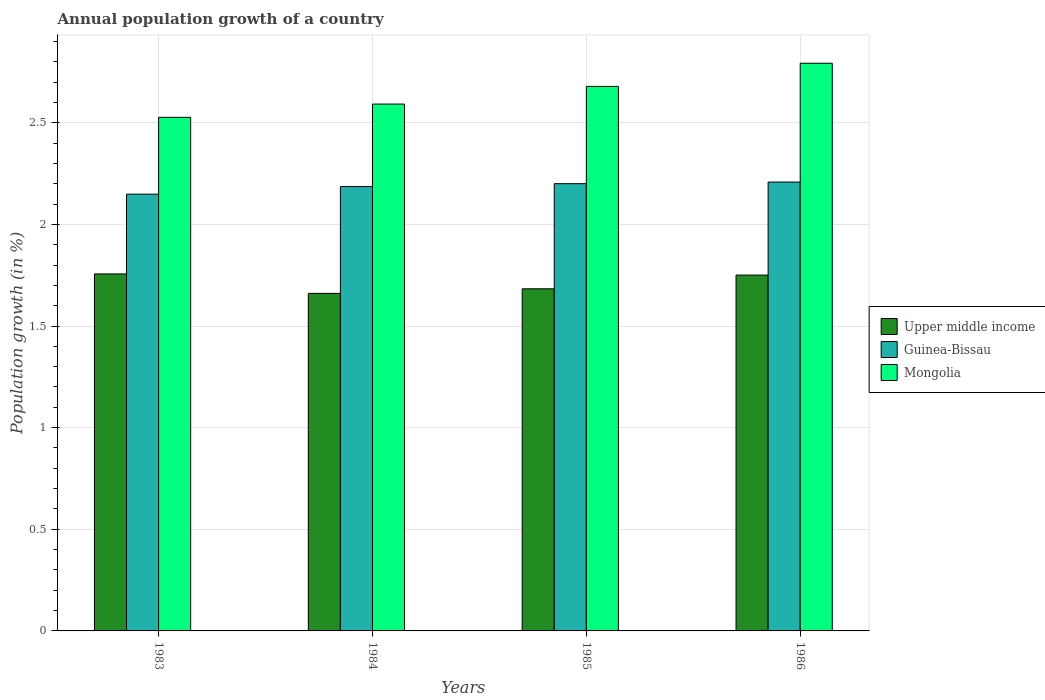How many groups of bars are there?
Provide a succinct answer. 4. Are the number of bars per tick equal to the number of legend labels?
Ensure brevity in your answer.  Yes. Are the number of bars on each tick of the X-axis equal?
Offer a very short reply. Yes. What is the label of the 2nd group of bars from the left?
Give a very brief answer. 1984. What is the annual population growth in Mongolia in 1986?
Give a very brief answer. 2.79. Across all years, what is the maximum annual population growth in Mongolia?
Keep it short and to the point. 2.79. Across all years, what is the minimum annual population growth in Guinea-Bissau?
Your response must be concise. 2.15. In which year was the annual population growth in Upper middle income minimum?
Offer a very short reply. 1984. What is the total annual population growth in Upper middle income in the graph?
Give a very brief answer. 6.85. What is the difference between the annual population growth in Upper middle income in 1983 and that in 1984?
Offer a terse response. 0.1. What is the difference between the annual population growth in Upper middle income in 1983 and the annual population growth in Mongolia in 1984?
Make the answer very short. -0.84. What is the average annual population growth in Upper middle income per year?
Offer a very short reply. 1.71. In the year 1985, what is the difference between the annual population growth in Guinea-Bissau and annual population growth in Upper middle income?
Ensure brevity in your answer.  0.52. What is the ratio of the annual population growth in Guinea-Bissau in 1983 to that in 1984?
Provide a short and direct response. 0.98. Is the difference between the annual population growth in Guinea-Bissau in 1984 and 1986 greater than the difference between the annual population growth in Upper middle income in 1984 and 1986?
Ensure brevity in your answer.  Yes. What is the difference between the highest and the second highest annual population growth in Mongolia?
Offer a very short reply. 0.11. What is the difference between the highest and the lowest annual population growth in Guinea-Bissau?
Offer a very short reply. 0.06. In how many years, is the annual population growth in Mongolia greater than the average annual population growth in Mongolia taken over all years?
Your answer should be compact. 2. Is the sum of the annual population growth in Mongolia in 1985 and 1986 greater than the maximum annual population growth in Upper middle income across all years?
Make the answer very short. Yes. What does the 3rd bar from the left in 1983 represents?
Keep it short and to the point. Mongolia. What does the 1st bar from the right in 1983 represents?
Make the answer very short. Mongolia. Is it the case that in every year, the sum of the annual population growth in Mongolia and annual population growth in Upper middle income is greater than the annual population growth in Guinea-Bissau?
Offer a very short reply. Yes. Are all the bars in the graph horizontal?
Your answer should be compact. No. What is the difference between two consecutive major ticks on the Y-axis?
Ensure brevity in your answer.  0.5. Are the values on the major ticks of Y-axis written in scientific E-notation?
Provide a succinct answer. No. Does the graph contain grids?
Your answer should be very brief. Yes. Where does the legend appear in the graph?
Keep it short and to the point. Center right. What is the title of the graph?
Provide a succinct answer. Annual population growth of a country. What is the label or title of the Y-axis?
Your answer should be very brief. Population growth (in %). What is the Population growth (in %) in Upper middle income in 1983?
Your answer should be very brief. 1.76. What is the Population growth (in %) in Guinea-Bissau in 1983?
Make the answer very short. 2.15. What is the Population growth (in %) in Mongolia in 1983?
Keep it short and to the point. 2.53. What is the Population growth (in %) in Upper middle income in 1984?
Provide a short and direct response. 1.66. What is the Population growth (in %) of Guinea-Bissau in 1984?
Keep it short and to the point. 2.19. What is the Population growth (in %) of Mongolia in 1984?
Your answer should be very brief. 2.59. What is the Population growth (in %) in Upper middle income in 1985?
Your response must be concise. 1.68. What is the Population growth (in %) of Guinea-Bissau in 1985?
Your answer should be compact. 2.2. What is the Population growth (in %) in Mongolia in 1985?
Provide a succinct answer. 2.68. What is the Population growth (in %) in Upper middle income in 1986?
Provide a short and direct response. 1.75. What is the Population growth (in %) of Guinea-Bissau in 1986?
Your answer should be compact. 2.21. What is the Population growth (in %) in Mongolia in 1986?
Ensure brevity in your answer.  2.79. Across all years, what is the maximum Population growth (in %) of Upper middle income?
Ensure brevity in your answer.  1.76. Across all years, what is the maximum Population growth (in %) in Guinea-Bissau?
Keep it short and to the point. 2.21. Across all years, what is the maximum Population growth (in %) in Mongolia?
Your response must be concise. 2.79. Across all years, what is the minimum Population growth (in %) of Upper middle income?
Keep it short and to the point. 1.66. Across all years, what is the minimum Population growth (in %) of Guinea-Bissau?
Your answer should be compact. 2.15. Across all years, what is the minimum Population growth (in %) of Mongolia?
Your answer should be very brief. 2.53. What is the total Population growth (in %) of Upper middle income in the graph?
Your answer should be compact. 6.85. What is the total Population growth (in %) of Guinea-Bissau in the graph?
Keep it short and to the point. 8.74. What is the total Population growth (in %) of Mongolia in the graph?
Your answer should be very brief. 10.59. What is the difference between the Population growth (in %) in Upper middle income in 1983 and that in 1984?
Ensure brevity in your answer.  0.1. What is the difference between the Population growth (in %) of Guinea-Bissau in 1983 and that in 1984?
Make the answer very short. -0.04. What is the difference between the Population growth (in %) of Mongolia in 1983 and that in 1984?
Your answer should be compact. -0.07. What is the difference between the Population growth (in %) in Upper middle income in 1983 and that in 1985?
Your answer should be very brief. 0.07. What is the difference between the Population growth (in %) in Guinea-Bissau in 1983 and that in 1985?
Provide a short and direct response. -0.05. What is the difference between the Population growth (in %) of Mongolia in 1983 and that in 1985?
Provide a short and direct response. -0.15. What is the difference between the Population growth (in %) of Upper middle income in 1983 and that in 1986?
Provide a succinct answer. 0.01. What is the difference between the Population growth (in %) in Guinea-Bissau in 1983 and that in 1986?
Make the answer very short. -0.06. What is the difference between the Population growth (in %) of Mongolia in 1983 and that in 1986?
Your response must be concise. -0.27. What is the difference between the Population growth (in %) in Upper middle income in 1984 and that in 1985?
Make the answer very short. -0.02. What is the difference between the Population growth (in %) of Guinea-Bissau in 1984 and that in 1985?
Your answer should be very brief. -0.01. What is the difference between the Population growth (in %) of Mongolia in 1984 and that in 1985?
Provide a short and direct response. -0.09. What is the difference between the Population growth (in %) of Upper middle income in 1984 and that in 1986?
Provide a short and direct response. -0.09. What is the difference between the Population growth (in %) in Guinea-Bissau in 1984 and that in 1986?
Your answer should be compact. -0.02. What is the difference between the Population growth (in %) of Mongolia in 1984 and that in 1986?
Your response must be concise. -0.2. What is the difference between the Population growth (in %) of Upper middle income in 1985 and that in 1986?
Your response must be concise. -0.07. What is the difference between the Population growth (in %) in Guinea-Bissau in 1985 and that in 1986?
Keep it short and to the point. -0.01. What is the difference between the Population growth (in %) in Mongolia in 1985 and that in 1986?
Your answer should be very brief. -0.11. What is the difference between the Population growth (in %) in Upper middle income in 1983 and the Population growth (in %) in Guinea-Bissau in 1984?
Provide a succinct answer. -0.43. What is the difference between the Population growth (in %) in Upper middle income in 1983 and the Population growth (in %) in Mongolia in 1984?
Your answer should be compact. -0.84. What is the difference between the Population growth (in %) in Guinea-Bissau in 1983 and the Population growth (in %) in Mongolia in 1984?
Ensure brevity in your answer.  -0.44. What is the difference between the Population growth (in %) in Upper middle income in 1983 and the Population growth (in %) in Guinea-Bissau in 1985?
Offer a very short reply. -0.44. What is the difference between the Population growth (in %) of Upper middle income in 1983 and the Population growth (in %) of Mongolia in 1985?
Your answer should be compact. -0.92. What is the difference between the Population growth (in %) in Guinea-Bissau in 1983 and the Population growth (in %) in Mongolia in 1985?
Ensure brevity in your answer.  -0.53. What is the difference between the Population growth (in %) of Upper middle income in 1983 and the Population growth (in %) of Guinea-Bissau in 1986?
Your answer should be very brief. -0.45. What is the difference between the Population growth (in %) in Upper middle income in 1983 and the Population growth (in %) in Mongolia in 1986?
Provide a succinct answer. -1.04. What is the difference between the Population growth (in %) in Guinea-Bissau in 1983 and the Population growth (in %) in Mongolia in 1986?
Offer a very short reply. -0.64. What is the difference between the Population growth (in %) of Upper middle income in 1984 and the Population growth (in %) of Guinea-Bissau in 1985?
Provide a succinct answer. -0.54. What is the difference between the Population growth (in %) of Upper middle income in 1984 and the Population growth (in %) of Mongolia in 1985?
Keep it short and to the point. -1.02. What is the difference between the Population growth (in %) of Guinea-Bissau in 1984 and the Population growth (in %) of Mongolia in 1985?
Ensure brevity in your answer.  -0.49. What is the difference between the Population growth (in %) in Upper middle income in 1984 and the Population growth (in %) in Guinea-Bissau in 1986?
Provide a succinct answer. -0.55. What is the difference between the Population growth (in %) in Upper middle income in 1984 and the Population growth (in %) in Mongolia in 1986?
Keep it short and to the point. -1.13. What is the difference between the Population growth (in %) of Guinea-Bissau in 1984 and the Population growth (in %) of Mongolia in 1986?
Offer a very short reply. -0.61. What is the difference between the Population growth (in %) of Upper middle income in 1985 and the Population growth (in %) of Guinea-Bissau in 1986?
Give a very brief answer. -0.53. What is the difference between the Population growth (in %) in Upper middle income in 1985 and the Population growth (in %) in Mongolia in 1986?
Your answer should be very brief. -1.11. What is the difference between the Population growth (in %) of Guinea-Bissau in 1985 and the Population growth (in %) of Mongolia in 1986?
Your response must be concise. -0.59. What is the average Population growth (in %) in Upper middle income per year?
Provide a short and direct response. 1.71. What is the average Population growth (in %) of Guinea-Bissau per year?
Your answer should be very brief. 2.19. What is the average Population growth (in %) in Mongolia per year?
Your answer should be very brief. 2.65. In the year 1983, what is the difference between the Population growth (in %) in Upper middle income and Population growth (in %) in Guinea-Bissau?
Give a very brief answer. -0.39. In the year 1983, what is the difference between the Population growth (in %) in Upper middle income and Population growth (in %) in Mongolia?
Ensure brevity in your answer.  -0.77. In the year 1983, what is the difference between the Population growth (in %) in Guinea-Bissau and Population growth (in %) in Mongolia?
Your response must be concise. -0.38. In the year 1984, what is the difference between the Population growth (in %) in Upper middle income and Population growth (in %) in Guinea-Bissau?
Offer a terse response. -0.53. In the year 1984, what is the difference between the Population growth (in %) in Upper middle income and Population growth (in %) in Mongolia?
Make the answer very short. -0.93. In the year 1984, what is the difference between the Population growth (in %) of Guinea-Bissau and Population growth (in %) of Mongolia?
Provide a succinct answer. -0.41. In the year 1985, what is the difference between the Population growth (in %) in Upper middle income and Population growth (in %) in Guinea-Bissau?
Ensure brevity in your answer.  -0.52. In the year 1985, what is the difference between the Population growth (in %) in Upper middle income and Population growth (in %) in Mongolia?
Keep it short and to the point. -1. In the year 1985, what is the difference between the Population growth (in %) of Guinea-Bissau and Population growth (in %) of Mongolia?
Provide a short and direct response. -0.48. In the year 1986, what is the difference between the Population growth (in %) in Upper middle income and Population growth (in %) in Guinea-Bissau?
Your answer should be compact. -0.46. In the year 1986, what is the difference between the Population growth (in %) of Upper middle income and Population growth (in %) of Mongolia?
Offer a very short reply. -1.04. In the year 1986, what is the difference between the Population growth (in %) of Guinea-Bissau and Population growth (in %) of Mongolia?
Provide a short and direct response. -0.58. What is the ratio of the Population growth (in %) in Upper middle income in 1983 to that in 1984?
Make the answer very short. 1.06. What is the ratio of the Population growth (in %) of Mongolia in 1983 to that in 1984?
Provide a short and direct response. 0.97. What is the ratio of the Population growth (in %) of Upper middle income in 1983 to that in 1985?
Offer a terse response. 1.04. What is the ratio of the Population growth (in %) of Guinea-Bissau in 1983 to that in 1985?
Keep it short and to the point. 0.98. What is the ratio of the Population growth (in %) of Mongolia in 1983 to that in 1985?
Provide a short and direct response. 0.94. What is the ratio of the Population growth (in %) of Guinea-Bissau in 1983 to that in 1986?
Give a very brief answer. 0.97. What is the ratio of the Population growth (in %) of Mongolia in 1983 to that in 1986?
Provide a short and direct response. 0.9. What is the ratio of the Population growth (in %) in Upper middle income in 1984 to that in 1985?
Your response must be concise. 0.99. What is the ratio of the Population growth (in %) of Guinea-Bissau in 1984 to that in 1985?
Make the answer very short. 0.99. What is the ratio of the Population growth (in %) in Mongolia in 1984 to that in 1985?
Provide a succinct answer. 0.97. What is the ratio of the Population growth (in %) of Upper middle income in 1984 to that in 1986?
Give a very brief answer. 0.95. What is the ratio of the Population growth (in %) in Guinea-Bissau in 1984 to that in 1986?
Keep it short and to the point. 0.99. What is the ratio of the Population growth (in %) of Mongolia in 1984 to that in 1986?
Your answer should be compact. 0.93. What is the ratio of the Population growth (in %) of Upper middle income in 1985 to that in 1986?
Your answer should be compact. 0.96. What is the ratio of the Population growth (in %) in Mongolia in 1985 to that in 1986?
Offer a terse response. 0.96. What is the difference between the highest and the second highest Population growth (in %) of Upper middle income?
Provide a succinct answer. 0.01. What is the difference between the highest and the second highest Population growth (in %) in Guinea-Bissau?
Make the answer very short. 0.01. What is the difference between the highest and the second highest Population growth (in %) in Mongolia?
Your answer should be compact. 0.11. What is the difference between the highest and the lowest Population growth (in %) of Upper middle income?
Provide a short and direct response. 0.1. What is the difference between the highest and the lowest Population growth (in %) of Guinea-Bissau?
Your answer should be compact. 0.06. What is the difference between the highest and the lowest Population growth (in %) of Mongolia?
Your answer should be very brief. 0.27. 